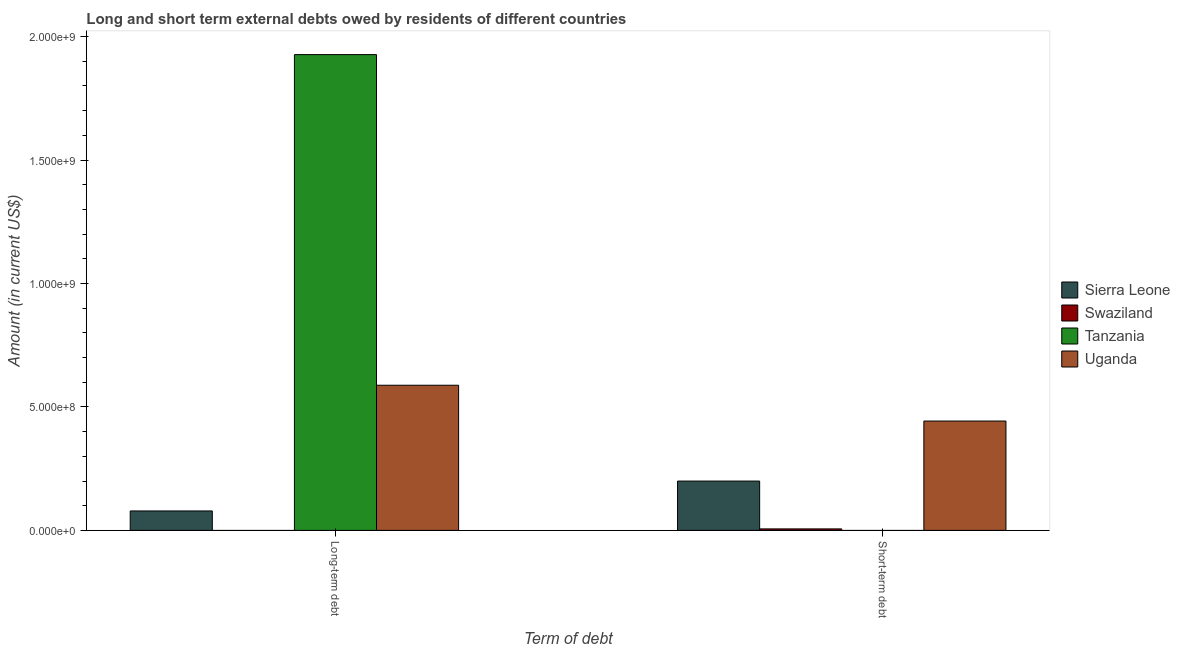How many groups of bars are there?
Give a very brief answer. 2. Are the number of bars per tick equal to the number of legend labels?
Give a very brief answer. No. What is the label of the 2nd group of bars from the left?
Your answer should be very brief. Short-term debt. What is the long-term debts owed by residents in Uganda?
Ensure brevity in your answer.  5.88e+08. Across all countries, what is the maximum short-term debts owed by residents?
Your response must be concise. 4.43e+08. Across all countries, what is the minimum long-term debts owed by residents?
Provide a short and direct response. 0. In which country was the short-term debts owed by residents maximum?
Provide a succinct answer. Uganda. What is the total short-term debts owed by residents in the graph?
Give a very brief answer. 6.49e+08. What is the difference between the short-term debts owed by residents in Sierra Leone and that in Swaziland?
Your response must be concise. 1.94e+08. What is the difference between the short-term debts owed by residents in Sierra Leone and the long-term debts owed by residents in Swaziland?
Provide a short and direct response. 2.00e+08. What is the average long-term debts owed by residents per country?
Your answer should be very brief. 6.48e+08. What is the difference between the short-term debts owed by residents and long-term debts owed by residents in Uganda?
Your answer should be compact. -1.45e+08. In how many countries, is the short-term debts owed by residents greater than 1800000000 US$?
Your answer should be compact. 0. What is the ratio of the long-term debts owed by residents in Tanzania to that in Uganda?
Your answer should be very brief. 3.28. In how many countries, is the short-term debts owed by residents greater than the average short-term debts owed by residents taken over all countries?
Your response must be concise. 2. How many countries are there in the graph?
Provide a short and direct response. 4. Are the values on the major ticks of Y-axis written in scientific E-notation?
Your answer should be very brief. Yes. Does the graph contain grids?
Your answer should be very brief. No. Where does the legend appear in the graph?
Offer a very short reply. Center right. How many legend labels are there?
Your response must be concise. 4. What is the title of the graph?
Give a very brief answer. Long and short term external debts owed by residents of different countries. Does "Indonesia" appear as one of the legend labels in the graph?
Your answer should be compact. No. What is the label or title of the X-axis?
Your answer should be very brief. Term of debt. What is the Amount (in current US$) of Sierra Leone in Long-term debt?
Give a very brief answer. 7.87e+07. What is the Amount (in current US$) in Swaziland in Long-term debt?
Ensure brevity in your answer.  0. What is the Amount (in current US$) in Tanzania in Long-term debt?
Your response must be concise. 1.93e+09. What is the Amount (in current US$) in Uganda in Long-term debt?
Provide a short and direct response. 5.88e+08. What is the Amount (in current US$) in Sierra Leone in Short-term debt?
Ensure brevity in your answer.  2.00e+08. What is the Amount (in current US$) in Swaziland in Short-term debt?
Provide a short and direct response. 6.00e+06. What is the Amount (in current US$) in Tanzania in Short-term debt?
Keep it short and to the point. 0. What is the Amount (in current US$) in Uganda in Short-term debt?
Ensure brevity in your answer.  4.43e+08. Across all Term of debt, what is the maximum Amount (in current US$) in Sierra Leone?
Your answer should be compact. 2.00e+08. Across all Term of debt, what is the maximum Amount (in current US$) in Swaziland?
Ensure brevity in your answer.  6.00e+06. Across all Term of debt, what is the maximum Amount (in current US$) of Tanzania?
Give a very brief answer. 1.93e+09. Across all Term of debt, what is the maximum Amount (in current US$) of Uganda?
Keep it short and to the point. 5.88e+08. Across all Term of debt, what is the minimum Amount (in current US$) in Sierra Leone?
Keep it short and to the point. 7.87e+07. Across all Term of debt, what is the minimum Amount (in current US$) of Swaziland?
Offer a very short reply. 0. Across all Term of debt, what is the minimum Amount (in current US$) in Tanzania?
Offer a terse response. 0. Across all Term of debt, what is the minimum Amount (in current US$) in Uganda?
Give a very brief answer. 4.43e+08. What is the total Amount (in current US$) in Sierra Leone in the graph?
Offer a very short reply. 2.78e+08. What is the total Amount (in current US$) of Swaziland in the graph?
Provide a succinct answer. 6.00e+06. What is the total Amount (in current US$) of Tanzania in the graph?
Your answer should be very brief. 1.93e+09. What is the total Amount (in current US$) of Uganda in the graph?
Ensure brevity in your answer.  1.03e+09. What is the difference between the Amount (in current US$) in Sierra Leone in Long-term debt and that in Short-term debt?
Offer a terse response. -1.21e+08. What is the difference between the Amount (in current US$) in Uganda in Long-term debt and that in Short-term debt?
Your answer should be very brief. 1.45e+08. What is the difference between the Amount (in current US$) in Sierra Leone in Long-term debt and the Amount (in current US$) in Swaziland in Short-term debt?
Make the answer very short. 7.27e+07. What is the difference between the Amount (in current US$) in Sierra Leone in Long-term debt and the Amount (in current US$) in Uganda in Short-term debt?
Keep it short and to the point. -3.64e+08. What is the difference between the Amount (in current US$) of Tanzania in Long-term debt and the Amount (in current US$) of Uganda in Short-term debt?
Provide a short and direct response. 1.48e+09. What is the average Amount (in current US$) in Sierra Leone per Term of debt?
Your response must be concise. 1.39e+08. What is the average Amount (in current US$) in Tanzania per Term of debt?
Make the answer very short. 9.64e+08. What is the average Amount (in current US$) of Uganda per Term of debt?
Make the answer very short. 5.15e+08. What is the difference between the Amount (in current US$) of Sierra Leone and Amount (in current US$) of Tanzania in Long-term debt?
Offer a very short reply. -1.85e+09. What is the difference between the Amount (in current US$) in Sierra Leone and Amount (in current US$) in Uganda in Long-term debt?
Give a very brief answer. -5.09e+08. What is the difference between the Amount (in current US$) in Tanzania and Amount (in current US$) in Uganda in Long-term debt?
Your answer should be very brief. 1.34e+09. What is the difference between the Amount (in current US$) of Sierra Leone and Amount (in current US$) of Swaziland in Short-term debt?
Give a very brief answer. 1.94e+08. What is the difference between the Amount (in current US$) in Sierra Leone and Amount (in current US$) in Uganda in Short-term debt?
Provide a succinct answer. -2.43e+08. What is the difference between the Amount (in current US$) of Swaziland and Amount (in current US$) of Uganda in Short-term debt?
Ensure brevity in your answer.  -4.37e+08. What is the ratio of the Amount (in current US$) of Sierra Leone in Long-term debt to that in Short-term debt?
Your answer should be compact. 0.39. What is the ratio of the Amount (in current US$) in Uganda in Long-term debt to that in Short-term debt?
Provide a succinct answer. 1.33. What is the difference between the highest and the second highest Amount (in current US$) in Sierra Leone?
Offer a terse response. 1.21e+08. What is the difference between the highest and the second highest Amount (in current US$) in Uganda?
Ensure brevity in your answer.  1.45e+08. What is the difference between the highest and the lowest Amount (in current US$) in Sierra Leone?
Make the answer very short. 1.21e+08. What is the difference between the highest and the lowest Amount (in current US$) of Swaziland?
Your response must be concise. 6.00e+06. What is the difference between the highest and the lowest Amount (in current US$) in Tanzania?
Keep it short and to the point. 1.93e+09. What is the difference between the highest and the lowest Amount (in current US$) of Uganda?
Give a very brief answer. 1.45e+08. 